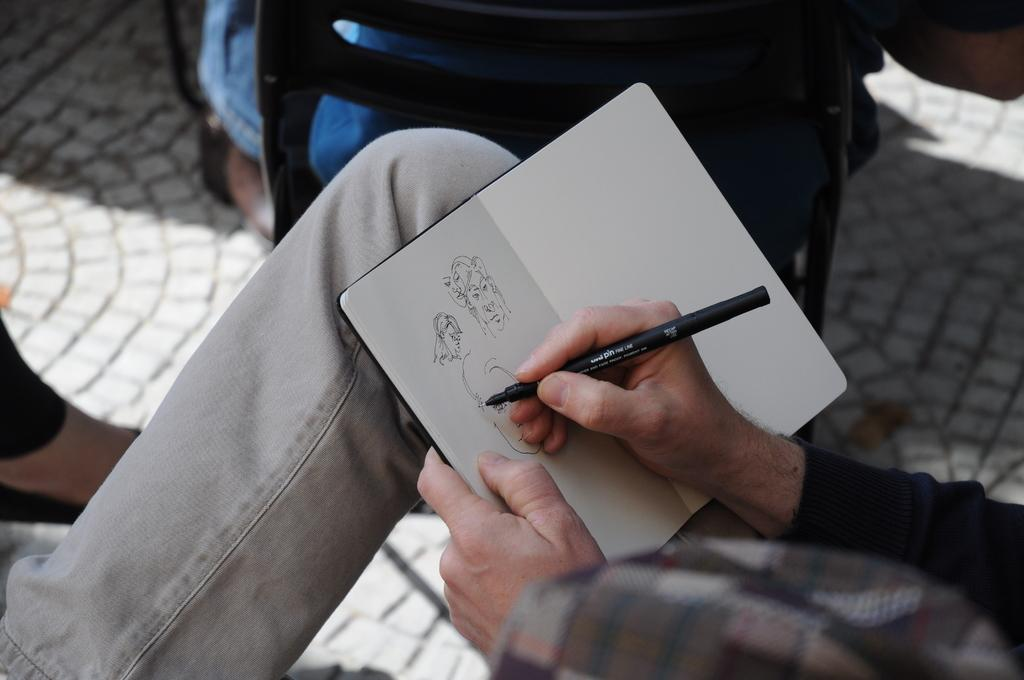Who or what can be seen in the image? There are people in the image. Where are the people located? The people are on the ground. What are the people holding in the image? One person is holding a book, and another person is holding a pen. What invention can be seen in the image? There is no invention present in the image. 